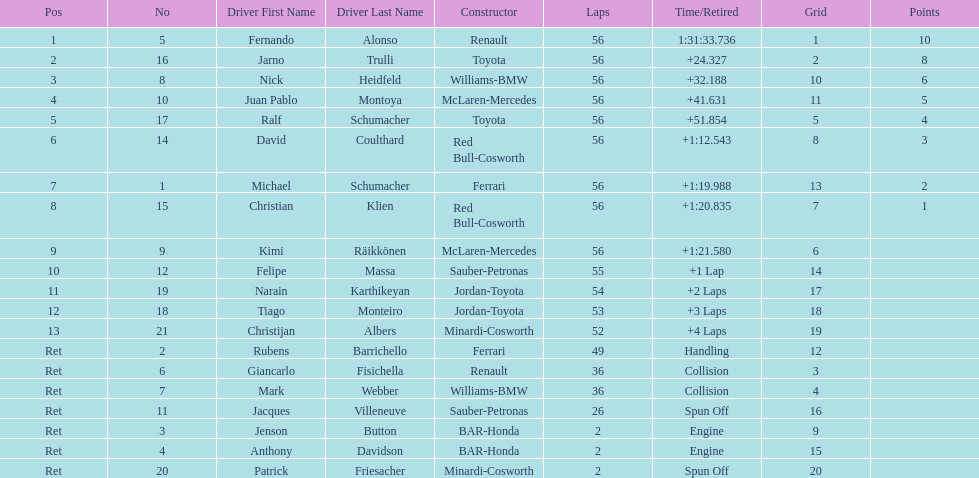Who was the last driver from the uk to actually finish the 56 laps? David Coulthard. 